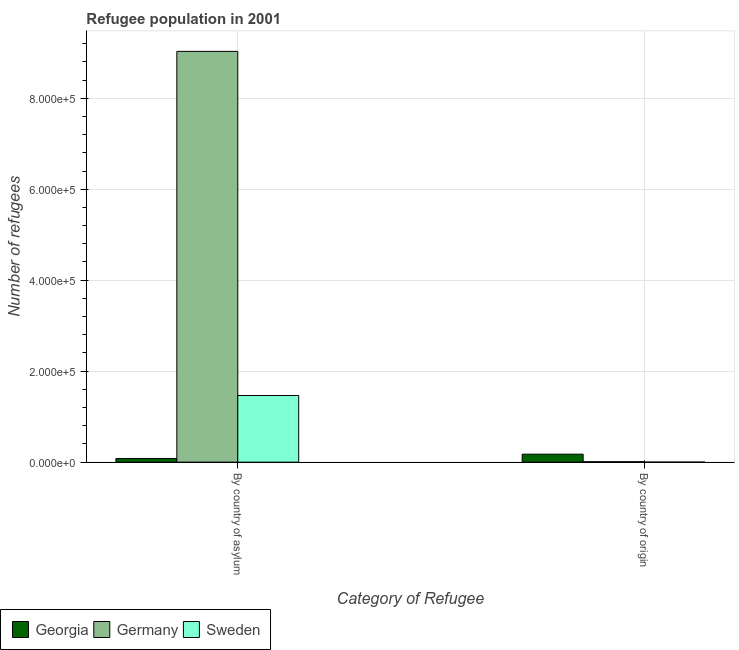How many different coloured bars are there?
Keep it short and to the point. 3. How many bars are there on the 2nd tick from the left?
Provide a succinct answer. 3. How many bars are there on the 1st tick from the right?
Your answer should be very brief. 3. What is the label of the 1st group of bars from the left?
Your answer should be very brief. By country of asylum. What is the number of refugees by country of origin in Germany?
Your response must be concise. 1033. Across all countries, what is the maximum number of refugees by country of asylum?
Offer a very short reply. 9.03e+05. Across all countries, what is the minimum number of refugees by country of origin?
Offer a terse response. 5. What is the total number of refugees by country of asylum in the graph?
Give a very brief answer. 1.06e+06. What is the difference between the number of refugees by country of origin in Germany and that in Sweden?
Give a very brief answer. 1028. What is the difference between the number of refugees by country of origin in Georgia and the number of refugees by country of asylum in Sweden?
Your answer should be compact. -1.29e+05. What is the average number of refugees by country of asylum per country?
Keep it short and to the point. 3.52e+05. What is the difference between the number of refugees by country of origin and number of refugees by country of asylum in Georgia?
Ensure brevity in your answer.  9597. In how many countries, is the number of refugees by country of origin greater than 280000 ?
Your answer should be very brief. 0. What is the ratio of the number of refugees by country of origin in Sweden to that in Georgia?
Ensure brevity in your answer.  0. In how many countries, is the number of refugees by country of asylum greater than the average number of refugees by country of asylum taken over all countries?
Keep it short and to the point. 1. How many bars are there?
Provide a succinct answer. 6. How many countries are there in the graph?
Provide a succinct answer. 3. Are the values on the major ticks of Y-axis written in scientific E-notation?
Offer a very short reply. Yes. Does the graph contain any zero values?
Your answer should be compact. No. Does the graph contain grids?
Keep it short and to the point. Yes. Where does the legend appear in the graph?
Offer a terse response. Bottom left. How many legend labels are there?
Offer a terse response. 3. What is the title of the graph?
Keep it short and to the point. Refugee population in 2001. Does "Cabo Verde" appear as one of the legend labels in the graph?
Provide a short and direct response. No. What is the label or title of the X-axis?
Make the answer very short. Category of Refugee. What is the label or title of the Y-axis?
Make the answer very short. Number of refugees. What is the Number of refugees in Georgia in By country of asylum?
Your response must be concise. 7901. What is the Number of refugees in Germany in By country of asylum?
Give a very brief answer. 9.03e+05. What is the Number of refugees of Sweden in By country of asylum?
Offer a terse response. 1.46e+05. What is the Number of refugees of Georgia in By country of origin?
Your response must be concise. 1.75e+04. What is the Number of refugees in Germany in By country of origin?
Make the answer very short. 1033. What is the Number of refugees in Sweden in By country of origin?
Provide a short and direct response. 5. Across all Category of Refugee, what is the maximum Number of refugees of Georgia?
Your response must be concise. 1.75e+04. Across all Category of Refugee, what is the maximum Number of refugees in Germany?
Make the answer very short. 9.03e+05. Across all Category of Refugee, what is the maximum Number of refugees of Sweden?
Keep it short and to the point. 1.46e+05. Across all Category of Refugee, what is the minimum Number of refugees of Georgia?
Keep it short and to the point. 7901. Across all Category of Refugee, what is the minimum Number of refugees in Germany?
Offer a terse response. 1033. Across all Category of Refugee, what is the minimum Number of refugees in Sweden?
Your answer should be compact. 5. What is the total Number of refugees of Georgia in the graph?
Your answer should be compact. 2.54e+04. What is the total Number of refugees of Germany in the graph?
Offer a very short reply. 9.04e+05. What is the total Number of refugees in Sweden in the graph?
Ensure brevity in your answer.  1.46e+05. What is the difference between the Number of refugees of Georgia in By country of asylum and that in By country of origin?
Your answer should be compact. -9597. What is the difference between the Number of refugees in Germany in By country of asylum and that in By country of origin?
Give a very brief answer. 9.02e+05. What is the difference between the Number of refugees of Sweden in By country of asylum and that in By country of origin?
Offer a terse response. 1.46e+05. What is the difference between the Number of refugees of Georgia in By country of asylum and the Number of refugees of Germany in By country of origin?
Offer a terse response. 6868. What is the difference between the Number of refugees of Georgia in By country of asylum and the Number of refugees of Sweden in By country of origin?
Offer a very short reply. 7896. What is the difference between the Number of refugees of Germany in By country of asylum and the Number of refugees of Sweden in By country of origin?
Your answer should be very brief. 9.03e+05. What is the average Number of refugees of Georgia per Category of Refugee?
Provide a succinct answer. 1.27e+04. What is the average Number of refugees of Germany per Category of Refugee?
Your answer should be very brief. 4.52e+05. What is the average Number of refugees in Sweden per Category of Refugee?
Offer a terse response. 7.32e+04. What is the difference between the Number of refugees of Georgia and Number of refugees of Germany in By country of asylum?
Your answer should be compact. -8.95e+05. What is the difference between the Number of refugees in Georgia and Number of refugees in Sweden in By country of asylum?
Your response must be concise. -1.39e+05. What is the difference between the Number of refugees in Germany and Number of refugees in Sweden in By country of asylum?
Make the answer very short. 7.57e+05. What is the difference between the Number of refugees of Georgia and Number of refugees of Germany in By country of origin?
Keep it short and to the point. 1.65e+04. What is the difference between the Number of refugees of Georgia and Number of refugees of Sweden in By country of origin?
Offer a terse response. 1.75e+04. What is the difference between the Number of refugees in Germany and Number of refugees in Sweden in By country of origin?
Provide a short and direct response. 1028. What is the ratio of the Number of refugees in Georgia in By country of asylum to that in By country of origin?
Provide a short and direct response. 0.45. What is the ratio of the Number of refugees in Germany in By country of asylum to that in By country of origin?
Make the answer very short. 874.15. What is the ratio of the Number of refugees in Sweden in By country of asylum to that in By country of origin?
Give a very brief answer. 2.93e+04. What is the difference between the highest and the second highest Number of refugees in Georgia?
Make the answer very short. 9597. What is the difference between the highest and the second highest Number of refugees of Germany?
Your response must be concise. 9.02e+05. What is the difference between the highest and the second highest Number of refugees of Sweden?
Offer a very short reply. 1.46e+05. What is the difference between the highest and the lowest Number of refugees of Georgia?
Ensure brevity in your answer.  9597. What is the difference between the highest and the lowest Number of refugees of Germany?
Make the answer very short. 9.02e+05. What is the difference between the highest and the lowest Number of refugees of Sweden?
Give a very brief answer. 1.46e+05. 